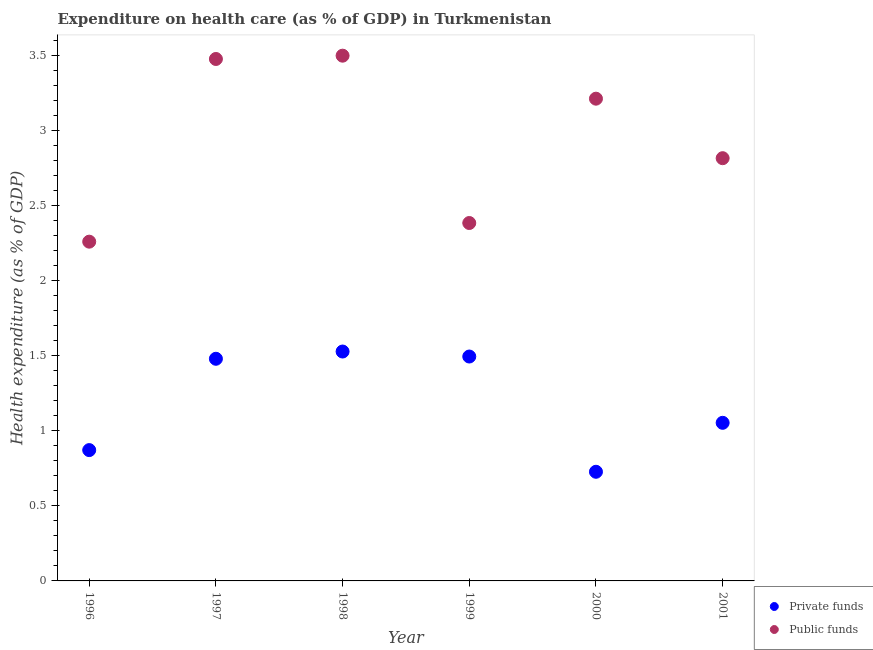Is the number of dotlines equal to the number of legend labels?
Give a very brief answer. Yes. What is the amount of public funds spent in healthcare in 2000?
Provide a short and direct response. 3.21. Across all years, what is the maximum amount of public funds spent in healthcare?
Make the answer very short. 3.5. Across all years, what is the minimum amount of public funds spent in healthcare?
Offer a terse response. 2.26. In which year was the amount of public funds spent in healthcare minimum?
Give a very brief answer. 1996. What is the total amount of private funds spent in healthcare in the graph?
Your response must be concise. 7.16. What is the difference between the amount of public funds spent in healthcare in 1996 and that in 2000?
Ensure brevity in your answer.  -0.95. What is the difference between the amount of private funds spent in healthcare in 1997 and the amount of public funds spent in healthcare in 2000?
Provide a succinct answer. -1.73. What is the average amount of private funds spent in healthcare per year?
Your response must be concise. 1.19. In the year 2000, what is the difference between the amount of public funds spent in healthcare and amount of private funds spent in healthcare?
Ensure brevity in your answer.  2.49. What is the ratio of the amount of public funds spent in healthcare in 1996 to that in 1997?
Offer a terse response. 0.65. Is the amount of private funds spent in healthcare in 2000 less than that in 2001?
Your answer should be very brief. Yes. What is the difference between the highest and the second highest amount of private funds spent in healthcare?
Your answer should be compact. 0.03. What is the difference between the highest and the lowest amount of private funds spent in healthcare?
Your answer should be very brief. 0.8. Does the amount of public funds spent in healthcare monotonically increase over the years?
Provide a short and direct response. No. Is the amount of private funds spent in healthcare strictly greater than the amount of public funds spent in healthcare over the years?
Provide a succinct answer. No. How many dotlines are there?
Make the answer very short. 2. What is the difference between two consecutive major ticks on the Y-axis?
Offer a terse response. 0.5. Does the graph contain any zero values?
Offer a very short reply. No. Does the graph contain grids?
Provide a succinct answer. No. Where does the legend appear in the graph?
Keep it short and to the point. Bottom right. What is the title of the graph?
Provide a short and direct response. Expenditure on health care (as % of GDP) in Turkmenistan. Does "Investment" appear as one of the legend labels in the graph?
Make the answer very short. No. What is the label or title of the Y-axis?
Ensure brevity in your answer.  Health expenditure (as % of GDP). What is the Health expenditure (as % of GDP) of Private funds in 1996?
Keep it short and to the point. 0.87. What is the Health expenditure (as % of GDP) in Public funds in 1996?
Offer a very short reply. 2.26. What is the Health expenditure (as % of GDP) of Private funds in 1997?
Your response must be concise. 1.48. What is the Health expenditure (as % of GDP) in Public funds in 1997?
Your answer should be compact. 3.48. What is the Health expenditure (as % of GDP) of Private funds in 1998?
Provide a succinct answer. 1.53. What is the Health expenditure (as % of GDP) of Public funds in 1998?
Make the answer very short. 3.5. What is the Health expenditure (as % of GDP) in Private funds in 1999?
Give a very brief answer. 1.5. What is the Health expenditure (as % of GDP) of Public funds in 1999?
Keep it short and to the point. 2.39. What is the Health expenditure (as % of GDP) in Private funds in 2000?
Ensure brevity in your answer.  0.73. What is the Health expenditure (as % of GDP) in Public funds in 2000?
Your answer should be very brief. 3.21. What is the Health expenditure (as % of GDP) in Private funds in 2001?
Your response must be concise. 1.05. What is the Health expenditure (as % of GDP) of Public funds in 2001?
Keep it short and to the point. 2.82. Across all years, what is the maximum Health expenditure (as % of GDP) in Private funds?
Give a very brief answer. 1.53. Across all years, what is the maximum Health expenditure (as % of GDP) in Public funds?
Give a very brief answer. 3.5. Across all years, what is the minimum Health expenditure (as % of GDP) in Private funds?
Your answer should be very brief. 0.73. Across all years, what is the minimum Health expenditure (as % of GDP) of Public funds?
Make the answer very short. 2.26. What is the total Health expenditure (as % of GDP) of Private funds in the graph?
Give a very brief answer. 7.16. What is the total Health expenditure (as % of GDP) in Public funds in the graph?
Offer a very short reply. 17.66. What is the difference between the Health expenditure (as % of GDP) in Private funds in 1996 and that in 1997?
Provide a succinct answer. -0.61. What is the difference between the Health expenditure (as % of GDP) of Public funds in 1996 and that in 1997?
Provide a succinct answer. -1.22. What is the difference between the Health expenditure (as % of GDP) in Private funds in 1996 and that in 1998?
Your answer should be compact. -0.66. What is the difference between the Health expenditure (as % of GDP) of Public funds in 1996 and that in 1998?
Make the answer very short. -1.24. What is the difference between the Health expenditure (as % of GDP) in Private funds in 1996 and that in 1999?
Your answer should be very brief. -0.62. What is the difference between the Health expenditure (as % of GDP) of Public funds in 1996 and that in 1999?
Ensure brevity in your answer.  -0.12. What is the difference between the Health expenditure (as % of GDP) in Private funds in 1996 and that in 2000?
Ensure brevity in your answer.  0.14. What is the difference between the Health expenditure (as % of GDP) in Public funds in 1996 and that in 2000?
Offer a very short reply. -0.95. What is the difference between the Health expenditure (as % of GDP) in Private funds in 1996 and that in 2001?
Your answer should be compact. -0.18. What is the difference between the Health expenditure (as % of GDP) in Public funds in 1996 and that in 2001?
Keep it short and to the point. -0.56. What is the difference between the Health expenditure (as % of GDP) of Private funds in 1997 and that in 1998?
Provide a succinct answer. -0.05. What is the difference between the Health expenditure (as % of GDP) in Public funds in 1997 and that in 1998?
Give a very brief answer. -0.02. What is the difference between the Health expenditure (as % of GDP) of Private funds in 1997 and that in 1999?
Your answer should be compact. -0.01. What is the difference between the Health expenditure (as % of GDP) of Public funds in 1997 and that in 1999?
Your answer should be very brief. 1.09. What is the difference between the Health expenditure (as % of GDP) in Private funds in 1997 and that in 2000?
Provide a short and direct response. 0.75. What is the difference between the Health expenditure (as % of GDP) in Public funds in 1997 and that in 2000?
Give a very brief answer. 0.26. What is the difference between the Health expenditure (as % of GDP) of Private funds in 1997 and that in 2001?
Make the answer very short. 0.43. What is the difference between the Health expenditure (as % of GDP) in Public funds in 1997 and that in 2001?
Your response must be concise. 0.66. What is the difference between the Health expenditure (as % of GDP) in Private funds in 1998 and that in 1999?
Provide a short and direct response. 0.03. What is the difference between the Health expenditure (as % of GDP) of Public funds in 1998 and that in 1999?
Your answer should be compact. 1.12. What is the difference between the Health expenditure (as % of GDP) of Private funds in 1998 and that in 2000?
Make the answer very short. 0.8. What is the difference between the Health expenditure (as % of GDP) of Public funds in 1998 and that in 2000?
Offer a very short reply. 0.29. What is the difference between the Health expenditure (as % of GDP) in Private funds in 1998 and that in 2001?
Offer a very short reply. 0.48. What is the difference between the Health expenditure (as % of GDP) of Public funds in 1998 and that in 2001?
Your answer should be compact. 0.68. What is the difference between the Health expenditure (as % of GDP) in Private funds in 1999 and that in 2000?
Offer a very short reply. 0.77. What is the difference between the Health expenditure (as % of GDP) in Public funds in 1999 and that in 2000?
Provide a short and direct response. -0.83. What is the difference between the Health expenditure (as % of GDP) of Private funds in 1999 and that in 2001?
Provide a succinct answer. 0.44. What is the difference between the Health expenditure (as % of GDP) in Public funds in 1999 and that in 2001?
Offer a terse response. -0.43. What is the difference between the Health expenditure (as % of GDP) of Private funds in 2000 and that in 2001?
Keep it short and to the point. -0.33. What is the difference between the Health expenditure (as % of GDP) in Public funds in 2000 and that in 2001?
Provide a short and direct response. 0.4. What is the difference between the Health expenditure (as % of GDP) of Private funds in 1996 and the Health expenditure (as % of GDP) of Public funds in 1997?
Provide a short and direct response. -2.61. What is the difference between the Health expenditure (as % of GDP) in Private funds in 1996 and the Health expenditure (as % of GDP) in Public funds in 1998?
Give a very brief answer. -2.63. What is the difference between the Health expenditure (as % of GDP) of Private funds in 1996 and the Health expenditure (as % of GDP) of Public funds in 1999?
Ensure brevity in your answer.  -1.51. What is the difference between the Health expenditure (as % of GDP) in Private funds in 1996 and the Health expenditure (as % of GDP) in Public funds in 2000?
Provide a succinct answer. -2.34. What is the difference between the Health expenditure (as % of GDP) of Private funds in 1996 and the Health expenditure (as % of GDP) of Public funds in 2001?
Your answer should be very brief. -1.95. What is the difference between the Health expenditure (as % of GDP) of Private funds in 1997 and the Health expenditure (as % of GDP) of Public funds in 1998?
Keep it short and to the point. -2.02. What is the difference between the Health expenditure (as % of GDP) in Private funds in 1997 and the Health expenditure (as % of GDP) in Public funds in 1999?
Offer a very short reply. -0.91. What is the difference between the Health expenditure (as % of GDP) in Private funds in 1997 and the Health expenditure (as % of GDP) in Public funds in 2000?
Provide a short and direct response. -1.73. What is the difference between the Health expenditure (as % of GDP) of Private funds in 1997 and the Health expenditure (as % of GDP) of Public funds in 2001?
Keep it short and to the point. -1.34. What is the difference between the Health expenditure (as % of GDP) of Private funds in 1998 and the Health expenditure (as % of GDP) of Public funds in 1999?
Provide a short and direct response. -0.86. What is the difference between the Health expenditure (as % of GDP) in Private funds in 1998 and the Health expenditure (as % of GDP) in Public funds in 2000?
Your answer should be compact. -1.69. What is the difference between the Health expenditure (as % of GDP) in Private funds in 1998 and the Health expenditure (as % of GDP) in Public funds in 2001?
Offer a very short reply. -1.29. What is the difference between the Health expenditure (as % of GDP) of Private funds in 1999 and the Health expenditure (as % of GDP) of Public funds in 2000?
Your answer should be compact. -1.72. What is the difference between the Health expenditure (as % of GDP) of Private funds in 1999 and the Health expenditure (as % of GDP) of Public funds in 2001?
Your answer should be very brief. -1.32. What is the difference between the Health expenditure (as % of GDP) in Private funds in 2000 and the Health expenditure (as % of GDP) in Public funds in 2001?
Your answer should be compact. -2.09. What is the average Health expenditure (as % of GDP) in Private funds per year?
Offer a very short reply. 1.19. What is the average Health expenditure (as % of GDP) in Public funds per year?
Keep it short and to the point. 2.94. In the year 1996, what is the difference between the Health expenditure (as % of GDP) of Private funds and Health expenditure (as % of GDP) of Public funds?
Keep it short and to the point. -1.39. In the year 1997, what is the difference between the Health expenditure (as % of GDP) in Private funds and Health expenditure (as % of GDP) in Public funds?
Offer a very short reply. -2. In the year 1998, what is the difference between the Health expenditure (as % of GDP) in Private funds and Health expenditure (as % of GDP) in Public funds?
Provide a short and direct response. -1.97. In the year 1999, what is the difference between the Health expenditure (as % of GDP) of Private funds and Health expenditure (as % of GDP) of Public funds?
Your response must be concise. -0.89. In the year 2000, what is the difference between the Health expenditure (as % of GDP) in Private funds and Health expenditure (as % of GDP) in Public funds?
Ensure brevity in your answer.  -2.49. In the year 2001, what is the difference between the Health expenditure (as % of GDP) of Private funds and Health expenditure (as % of GDP) of Public funds?
Your answer should be compact. -1.76. What is the ratio of the Health expenditure (as % of GDP) in Private funds in 1996 to that in 1997?
Provide a succinct answer. 0.59. What is the ratio of the Health expenditure (as % of GDP) in Public funds in 1996 to that in 1997?
Your answer should be compact. 0.65. What is the ratio of the Health expenditure (as % of GDP) of Private funds in 1996 to that in 1998?
Ensure brevity in your answer.  0.57. What is the ratio of the Health expenditure (as % of GDP) in Public funds in 1996 to that in 1998?
Your answer should be very brief. 0.65. What is the ratio of the Health expenditure (as % of GDP) of Private funds in 1996 to that in 1999?
Your response must be concise. 0.58. What is the ratio of the Health expenditure (as % of GDP) of Public funds in 1996 to that in 1999?
Make the answer very short. 0.95. What is the ratio of the Health expenditure (as % of GDP) in Private funds in 1996 to that in 2000?
Give a very brief answer. 1.2. What is the ratio of the Health expenditure (as % of GDP) in Public funds in 1996 to that in 2000?
Your response must be concise. 0.7. What is the ratio of the Health expenditure (as % of GDP) in Private funds in 1996 to that in 2001?
Your answer should be compact. 0.83. What is the ratio of the Health expenditure (as % of GDP) in Public funds in 1996 to that in 2001?
Make the answer very short. 0.8. What is the ratio of the Health expenditure (as % of GDP) of Private funds in 1997 to that in 1998?
Your answer should be compact. 0.97. What is the ratio of the Health expenditure (as % of GDP) of Private funds in 1997 to that in 1999?
Make the answer very short. 0.99. What is the ratio of the Health expenditure (as % of GDP) in Public funds in 1997 to that in 1999?
Your answer should be very brief. 1.46. What is the ratio of the Health expenditure (as % of GDP) of Private funds in 1997 to that in 2000?
Your answer should be very brief. 2.04. What is the ratio of the Health expenditure (as % of GDP) in Public funds in 1997 to that in 2000?
Make the answer very short. 1.08. What is the ratio of the Health expenditure (as % of GDP) of Private funds in 1997 to that in 2001?
Give a very brief answer. 1.41. What is the ratio of the Health expenditure (as % of GDP) in Public funds in 1997 to that in 2001?
Your answer should be compact. 1.23. What is the ratio of the Health expenditure (as % of GDP) of Private funds in 1998 to that in 1999?
Give a very brief answer. 1.02. What is the ratio of the Health expenditure (as % of GDP) in Public funds in 1998 to that in 1999?
Offer a terse response. 1.47. What is the ratio of the Health expenditure (as % of GDP) in Private funds in 1998 to that in 2000?
Provide a short and direct response. 2.1. What is the ratio of the Health expenditure (as % of GDP) in Public funds in 1998 to that in 2000?
Give a very brief answer. 1.09. What is the ratio of the Health expenditure (as % of GDP) in Private funds in 1998 to that in 2001?
Ensure brevity in your answer.  1.45. What is the ratio of the Health expenditure (as % of GDP) in Public funds in 1998 to that in 2001?
Make the answer very short. 1.24. What is the ratio of the Health expenditure (as % of GDP) of Private funds in 1999 to that in 2000?
Keep it short and to the point. 2.06. What is the ratio of the Health expenditure (as % of GDP) of Public funds in 1999 to that in 2000?
Your answer should be very brief. 0.74. What is the ratio of the Health expenditure (as % of GDP) in Private funds in 1999 to that in 2001?
Offer a very short reply. 1.42. What is the ratio of the Health expenditure (as % of GDP) of Public funds in 1999 to that in 2001?
Provide a short and direct response. 0.85. What is the ratio of the Health expenditure (as % of GDP) in Private funds in 2000 to that in 2001?
Make the answer very short. 0.69. What is the ratio of the Health expenditure (as % of GDP) in Public funds in 2000 to that in 2001?
Your answer should be very brief. 1.14. What is the difference between the highest and the second highest Health expenditure (as % of GDP) in Private funds?
Your answer should be compact. 0.03. What is the difference between the highest and the second highest Health expenditure (as % of GDP) in Public funds?
Give a very brief answer. 0.02. What is the difference between the highest and the lowest Health expenditure (as % of GDP) in Private funds?
Provide a short and direct response. 0.8. What is the difference between the highest and the lowest Health expenditure (as % of GDP) in Public funds?
Your answer should be compact. 1.24. 